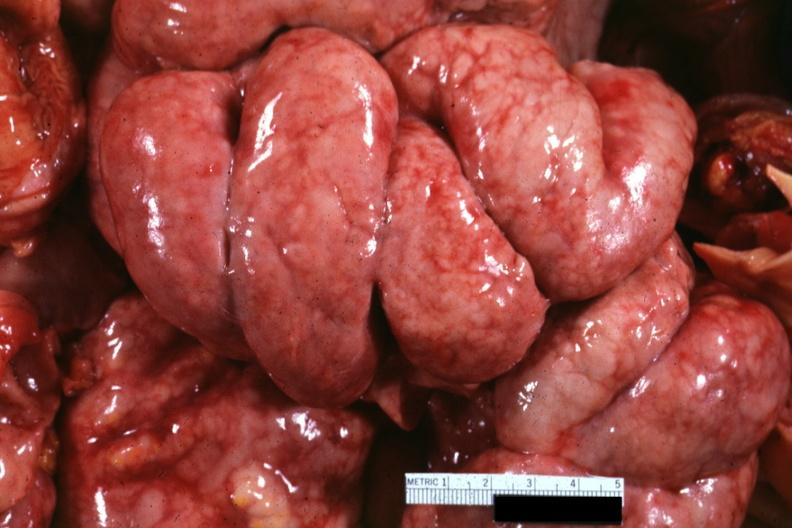what does this image show?
Answer the question using a single word or phrase. Bowel in situ with diffuse thickening of peritoneal surfaces due to metastatic carcinoma breast primary i think 